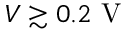Convert formula to latex. <formula><loc_0><loc_0><loc_500><loc_500>V \gtrsim 0 . 2 V</formula> 